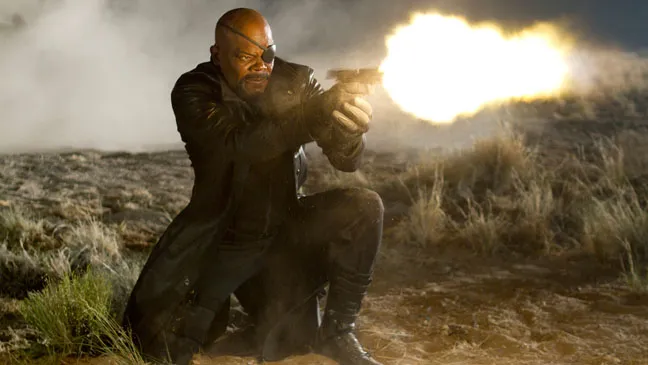Let's imagine he found something important just off-screen. What do you think it could be? Envisioning the high-stakes context of this scene, he could have discovered a hidden cache of secret documents or a piece of advanced technology that holds crucial data. Alternatively, he might have stumbled upon an ancient artifact imbued with untapped power, essential for preventing a looming catastrophe. It could even be something personal and poignant, such as an old locket or a photograph belonging to a long-lost comrade, adding an emotional depth to his mission. What if this moment is a turning point in his quest? Describe that scenario. This moment represents a turning point in his quest. For months, he has tirelessly pursued a shadowy organization responsible for destabilizing nations. Kneeling on this desolate ground, he finds a small device, barely noticeable among the rocks. It's an encrypted drive containing undeniable evidence of the organization's plans and their leader's identity. The discovery reignites his determination. With renewed vigor and the weight of the evidence, he knows this is his chance to strike decisively and dismantle the threat once and for all. The surrounding dust and chaos reflect the sense of turmoil and urgency, but also the dawn of hope and justice. 